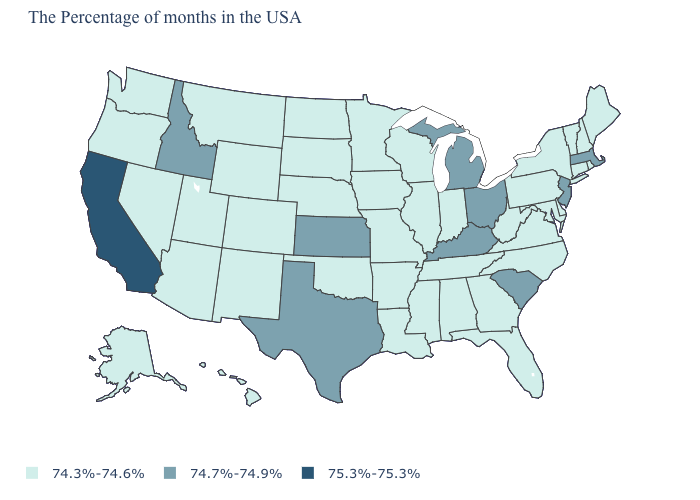Does the map have missing data?
Concise answer only. No. Name the states that have a value in the range 74.3%-74.6%?
Concise answer only. Maine, Rhode Island, New Hampshire, Vermont, Connecticut, New York, Delaware, Maryland, Pennsylvania, Virginia, North Carolina, West Virginia, Florida, Georgia, Indiana, Alabama, Tennessee, Wisconsin, Illinois, Mississippi, Louisiana, Missouri, Arkansas, Minnesota, Iowa, Nebraska, Oklahoma, South Dakota, North Dakota, Wyoming, Colorado, New Mexico, Utah, Montana, Arizona, Nevada, Washington, Oregon, Alaska, Hawaii. How many symbols are there in the legend?
Answer briefly. 3. What is the value of California?
Short answer required. 75.3%-75.3%. What is the value of Oregon?
Short answer required. 74.3%-74.6%. Is the legend a continuous bar?
Answer briefly. No. What is the value of Texas?
Quick response, please. 74.7%-74.9%. Among the states that border Louisiana , does Mississippi have the lowest value?
Short answer required. Yes. What is the value of Hawaii?
Concise answer only. 74.3%-74.6%. What is the lowest value in states that border North Carolina?
Answer briefly. 74.3%-74.6%. Name the states that have a value in the range 74.7%-74.9%?
Short answer required. Massachusetts, New Jersey, South Carolina, Ohio, Michigan, Kentucky, Kansas, Texas, Idaho. Does South Carolina have a lower value than California?
Concise answer only. Yes. Name the states that have a value in the range 74.3%-74.6%?
Quick response, please. Maine, Rhode Island, New Hampshire, Vermont, Connecticut, New York, Delaware, Maryland, Pennsylvania, Virginia, North Carolina, West Virginia, Florida, Georgia, Indiana, Alabama, Tennessee, Wisconsin, Illinois, Mississippi, Louisiana, Missouri, Arkansas, Minnesota, Iowa, Nebraska, Oklahoma, South Dakota, North Dakota, Wyoming, Colorado, New Mexico, Utah, Montana, Arizona, Nevada, Washington, Oregon, Alaska, Hawaii. What is the value of Illinois?
Answer briefly. 74.3%-74.6%. 